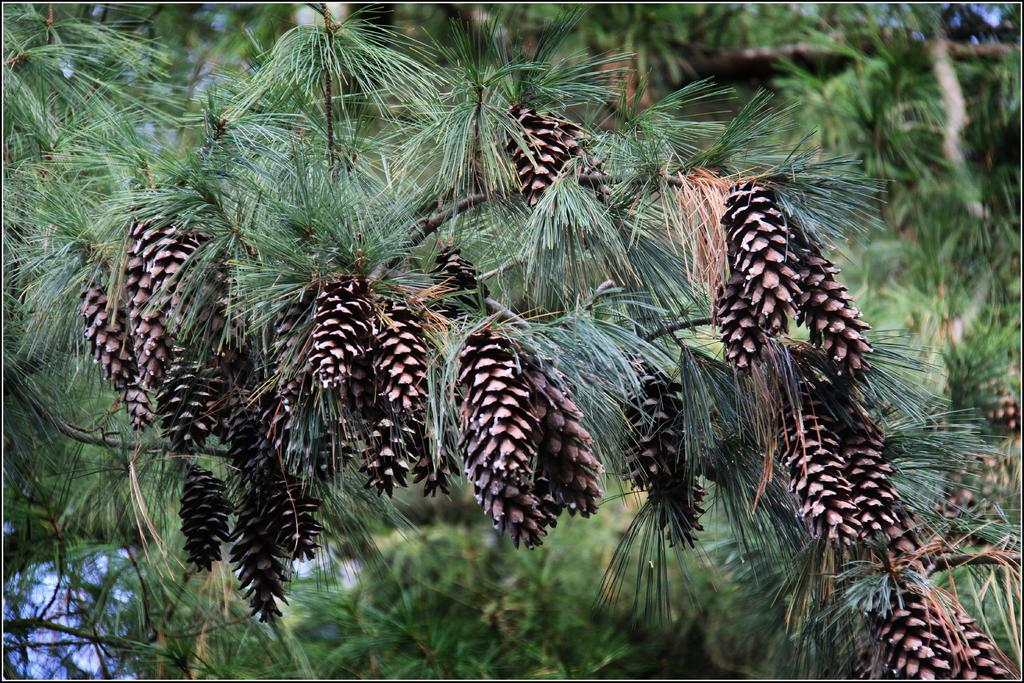What type of vegetation can be seen in the image? There are pines and trees in the image. Can you describe the landscape in the image? The image features a landscape with pines and trees. What type of scarf is draped over the tree in the image? There is no scarf present in the image; it only features pines and trees. 